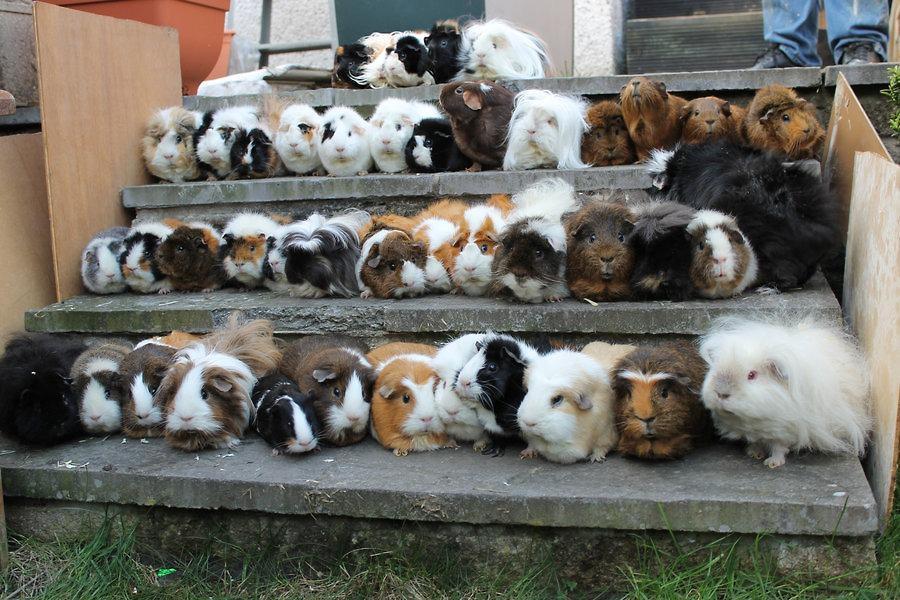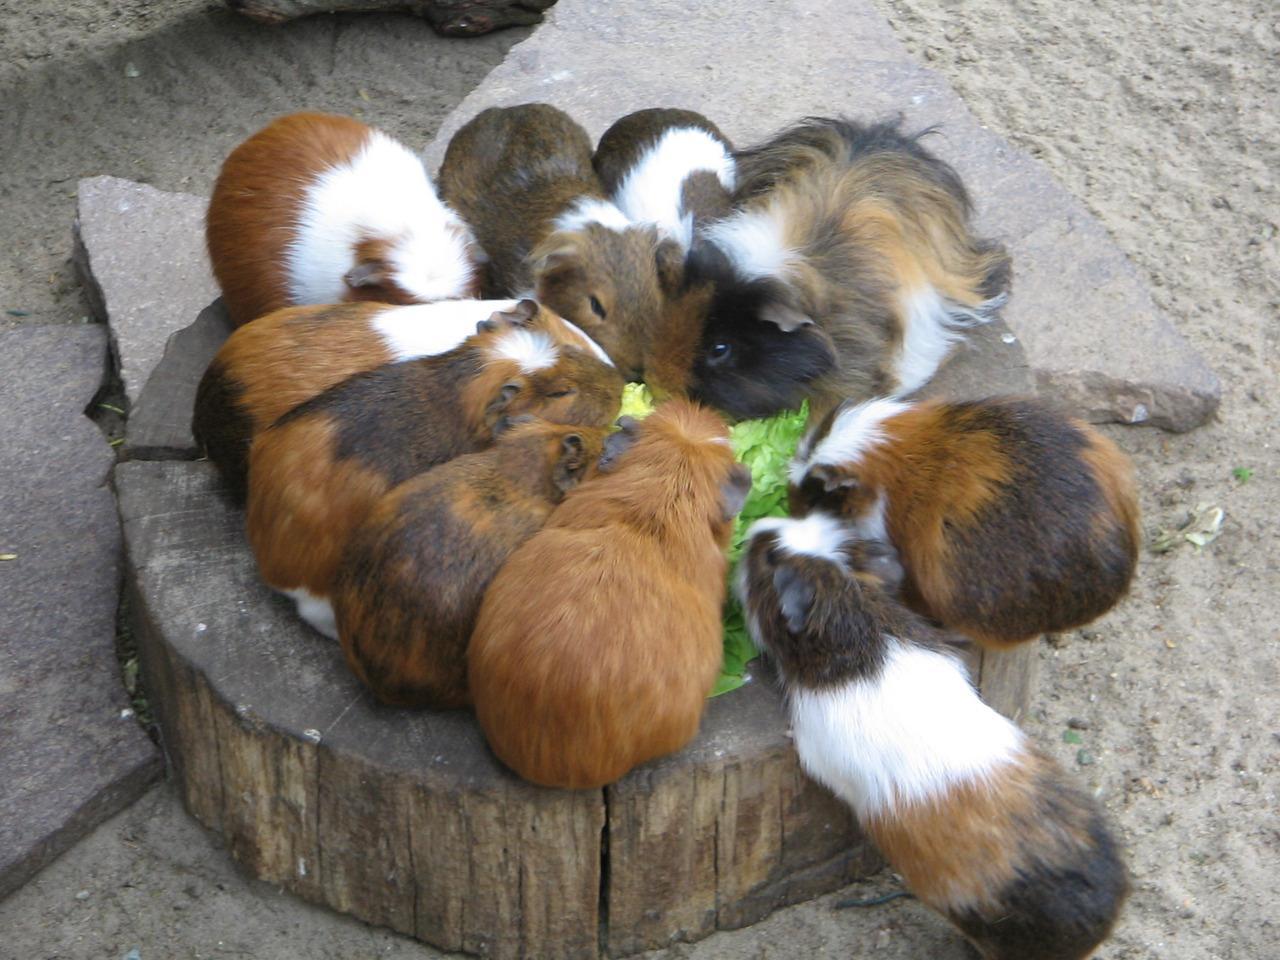The first image is the image on the left, the second image is the image on the right. Evaluate the accuracy of this statement regarding the images: "All of the guinea pigs are outside and some of them are eating greens.". Is it true? Answer yes or no. Yes. The first image is the image on the left, the second image is the image on the right. Examine the images to the left and right. Is the description "An image shows guinea pigs gathered around something """"organic"""" to eat." accurate? Answer yes or no. Yes. 